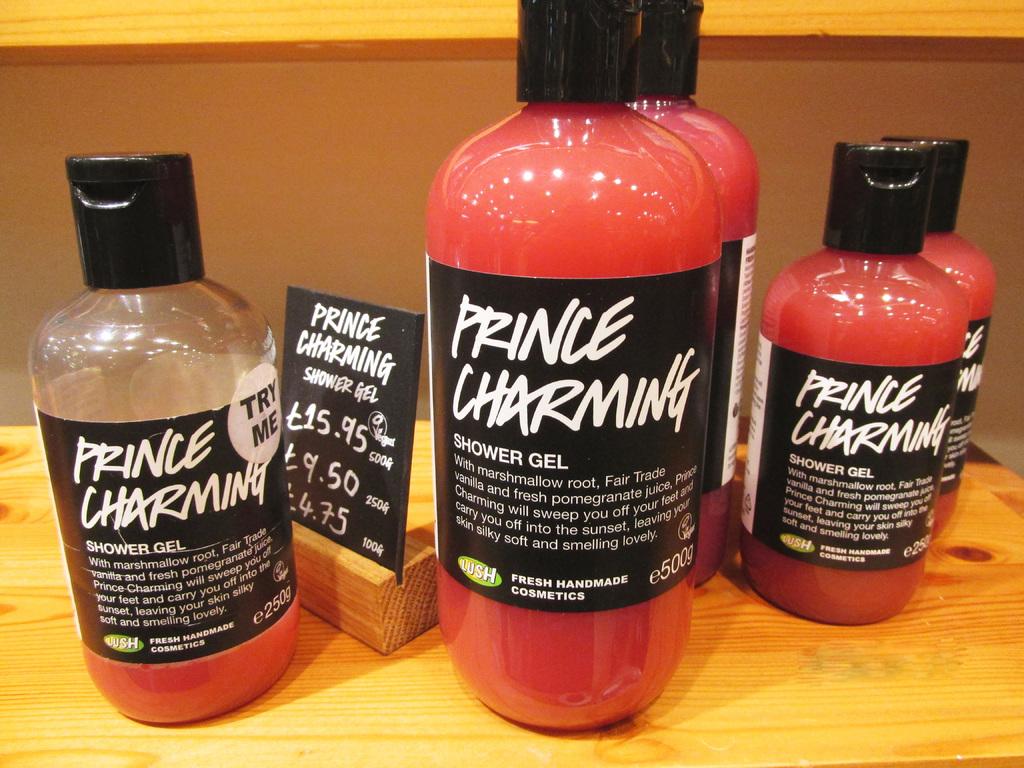What's the name of the shower gel?
Your answer should be compact. Prince charming. What kind of root is used to make this shower gel?
Offer a very short reply. Marshmallow. 